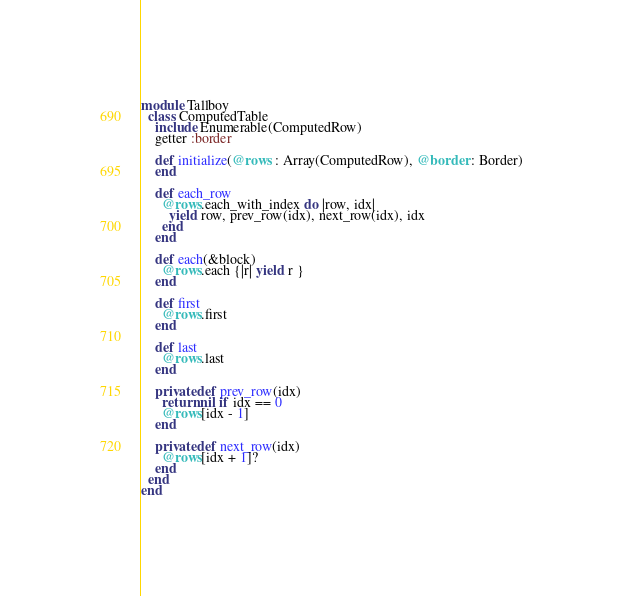<code> <loc_0><loc_0><loc_500><loc_500><_Crystal_>module Tallboy
  class ComputedTable
    include Enumerable(ComputedRow)
    getter :border

    def initialize(@rows : Array(ComputedRow), @border : Border)
    end

    def each_row
      @rows.each_with_index do |row, idx|
        yield row, prev_row(idx), next_row(idx), idx
      end
    end

    def each(&block)
      @rows.each {|r| yield r }
    end

    def first
      @rows.first
    end

    def last
      @rows.last
    end  

    private def prev_row(idx)
      return nil if idx == 0
      @rows[idx - 1]
    end

    private def next_row(idx)
      @rows[idx + 1]?
    end  
  end
end</code> 